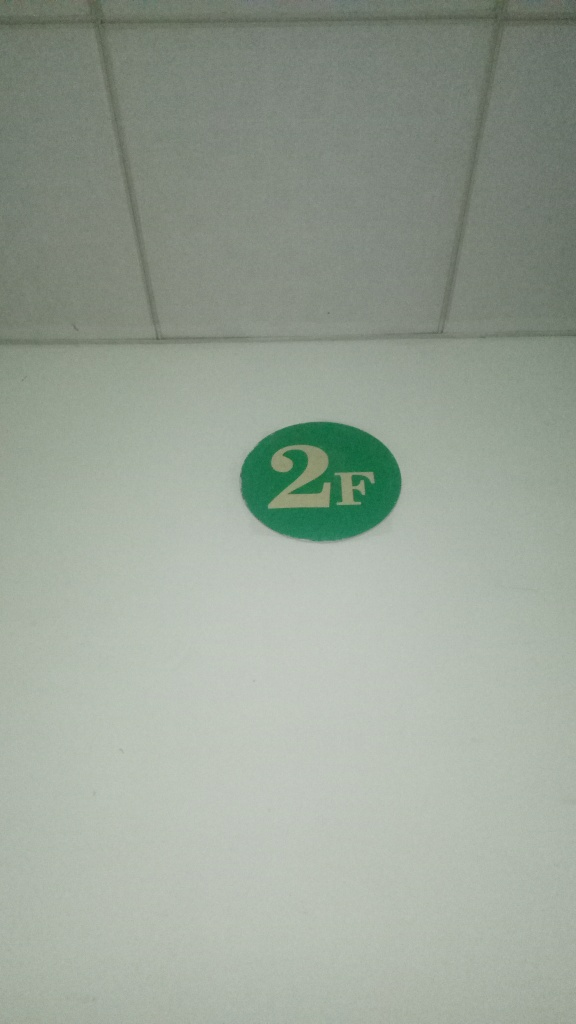What is the overall clarity of the image?
A. unclear
B. high
C. low The clarity of the image is relatively low. While the central element, a green circle with the number '2F' is visible and legible, the surrounding areas appear to lack detail due to the lighting conditions or camera focus. This results in a perception of low overall clarity, particularly when evaluating the textures and edges surrounding the central symbol. 